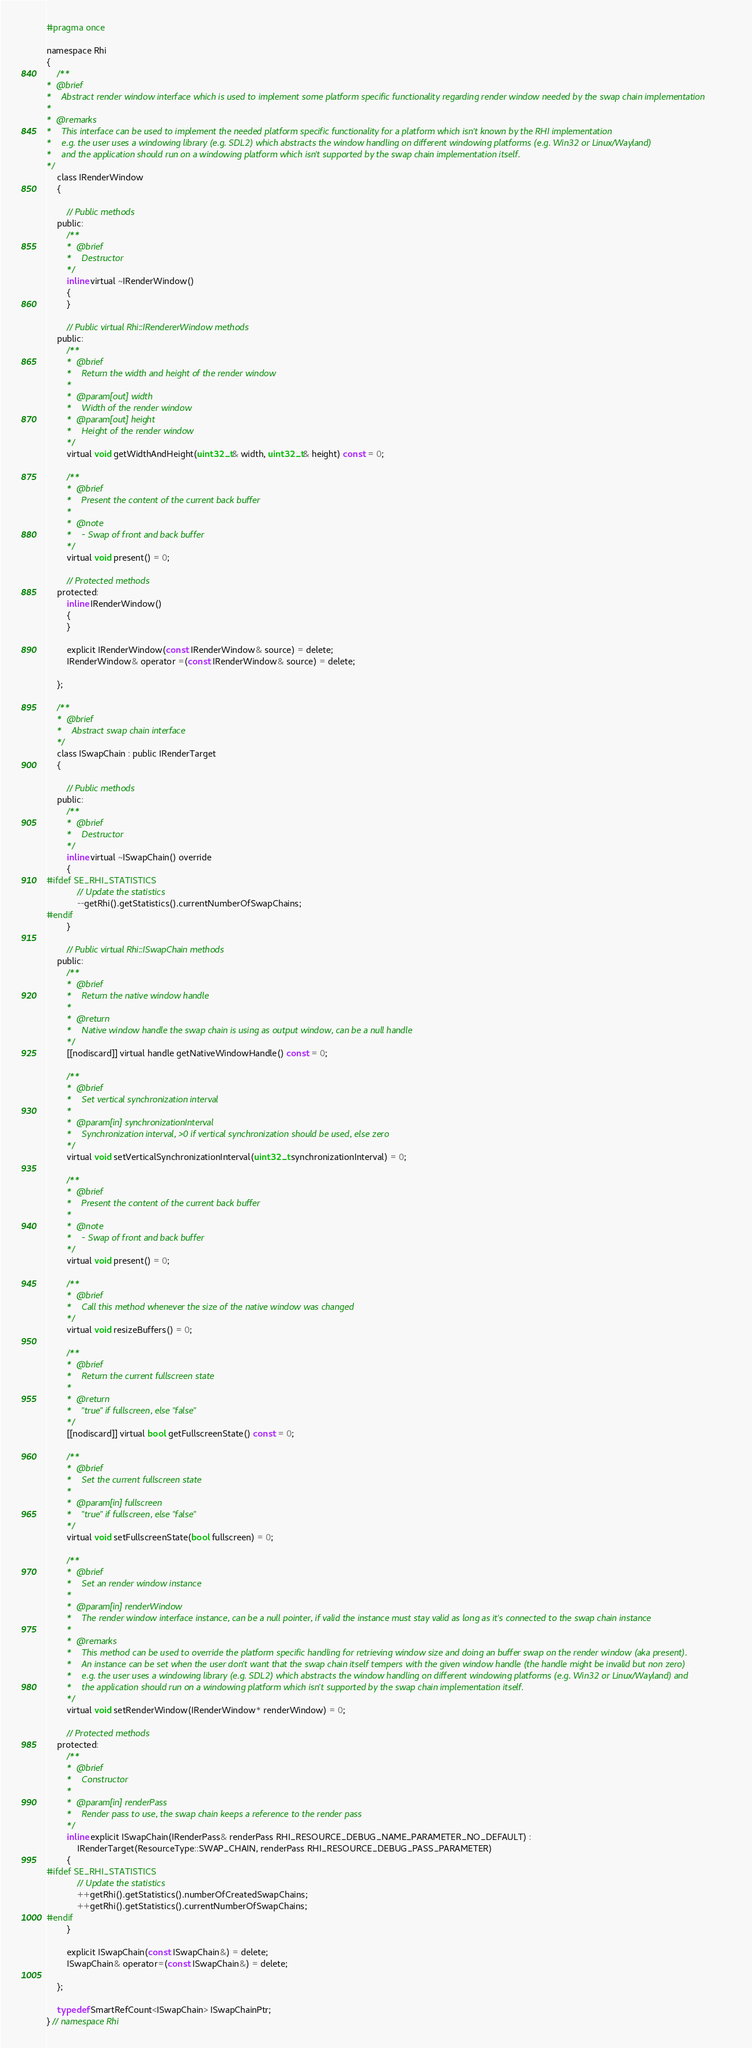Convert code to text. <code><loc_0><loc_0><loc_500><loc_500><_C_>#pragma once

namespace Rhi
{
	/**
*  @brief
*    Abstract render window interface which is used to implement some platform specific functionality regarding render window needed by the swap chain implementation
*
*  @remarks
*    This interface can be used to implement the needed platform specific functionality for a platform which isn't known by the RHI implementation
*    e.g. the user uses a windowing library (e.g. SDL2) which abstracts the window handling on different windowing platforms (e.g. Win32 or Linux/Wayland)
*    and the application should run on a windowing platform which isn't supported by the swap chain implementation itself.
*/
	class IRenderWindow
	{

		// Public methods
	public:
		/**
		*  @brief
		*    Destructor
		*/
		inline virtual ~IRenderWindow()
		{
		}

		// Public virtual Rhi::IRendererWindow methods
	public:
		/**
		*  @brief
		*    Return the width and height of the render window
		*
		*  @param[out] width
		*    Width of the render window
		*  @param[out] height
		*    Height of the render window
		*/
		virtual void getWidthAndHeight(uint32_t& width, uint32_t& height) const = 0;

		/**
		*  @brief
		*    Present the content of the current back buffer
		*
		*  @note
		*    - Swap of front and back buffer
		*/
		virtual void present() = 0;

		// Protected methods
	protected:
		inline IRenderWindow()
		{
		}

		explicit IRenderWindow(const IRenderWindow& source) = delete;
		IRenderWindow& operator =(const IRenderWindow& source) = delete;

	};

	/**
	*  @brief
	*    Abstract swap chain interface
	*/
	class ISwapChain : public IRenderTarget
	{

		// Public methods
	public:
		/**
		*  @brief
		*    Destructor
		*/
		inline virtual ~ISwapChain() override
		{
#ifdef SE_RHI_STATISTICS
			// Update the statistics
			--getRhi().getStatistics().currentNumberOfSwapChains;
#endif
		}

		// Public virtual Rhi::ISwapChain methods
	public:
		/**
		*  @brief
		*    Return the native window handle
		*
		*  @return
		*    Native window handle the swap chain is using as output window, can be a null handle
		*/
		[[nodiscard]] virtual handle getNativeWindowHandle() const = 0;

		/**
		*  @brief
		*    Set vertical synchronization interval
		*
		*  @param[in] synchronizationInterval
		*    Synchronization interval, >0 if vertical synchronization should be used, else zero
		*/
		virtual void setVerticalSynchronizationInterval(uint32_t synchronizationInterval) = 0;

		/**
		*  @brief
		*    Present the content of the current back buffer
		*
		*  @note
		*    - Swap of front and back buffer
		*/
		virtual void present() = 0;

		/**
		*  @brief
		*    Call this method whenever the size of the native window was changed
		*/
		virtual void resizeBuffers() = 0;

		/**
		*  @brief
		*    Return the current fullscreen state
		*
		*  @return
		*    "true" if fullscreen, else "false"
		*/
		[[nodiscard]] virtual bool getFullscreenState() const = 0;

		/**
		*  @brief
		*    Set the current fullscreen state
		*
		*  @param[in] fullscreen
		*    "true" if fullscreen, else "false"
		*/
		virtual void setFullscreenState(bool fullscreen) = 0;

		/**
		*  @brief
		*    Set an render window instance
		*
		*  @param[in] renderWindow
		*    The render window interface instance, can be a null pointer, if valid the instance must stay valid as long as it's connected to the swap chain instance
		*
		*  @remarks
		*    This method can be used to override the platform specific handling for retrieving window size and doing an buffer swap on the render window (aka present).
		*    An instance can be set when the user don't want that the swap chain itself tempers with the given window handle (the handle might be invalid but non zero)
		*    e.g. the user uses a windowing library (e.g. SDL2) which abstracts the window handling on different windowing platforms (e.g. Win32 or Linux/Wayland) and
		*    the application should run on a windowing platform which isn't supported by the swap chain implementation itself.
		*/
		virtual void setRenderWindow(IRenderWindow* renderWindow) = 0;

		// Protected methods
	protected:
		/**
		*  @brief
		*    Constructor
		*
		*  @param[in] renderPass
		*    Render pass to use, the swap chain keeps a reference to the render pass
		*/
		inline explicit ISwapChain(IRenderPass& renderPass RHI_RESOURCE_DEBUG_NAME_PARAMETER_NO_DEFAULT) :
			IRenderTarget(ResourceType::SWAP_CHAIN, renderPass RHI_RESOURCE_DEBUG_PASS_PARAMETER)
		{
#ifdef SE_RHI_STATISTICS
			// Update the statistics
			++getRhi().getStatistics().numberOfCreatedSwapChains;
			++getRhi().getStatistics().currentNumberOfSwapChains;
#endif
		}

		explicit ISwapChain(const ISwapChain&) = delete;
		ISwapChain& operator=(const ISwapChain&) = delete;

	};

	typedef SmartRefCount<ISwapChain> ISwapChainPtr;
} // namespace Rhi</code> 